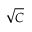Convert formula to latex. <formula><loc_0><loc_0><loc_500><loc_500>\sqrt { C }</formula> 